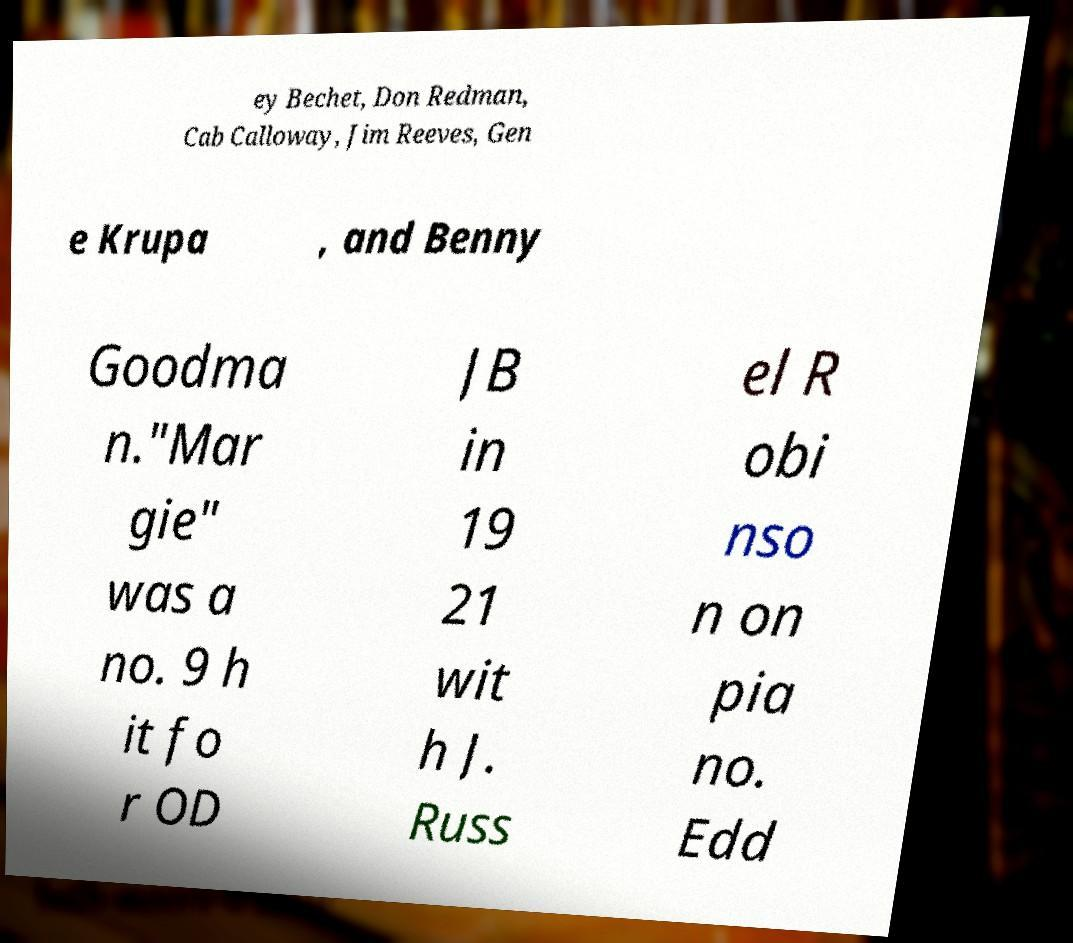I need the written content from this picture converted into text. Can you do that? ey Bechet, Don Redman, Cab Calloway, Jim Reeves, Gen e Krupa , and Benny Goodma n."Mar gie" was a no. 9 h it fo r OD JB in 19 21 wit h J. Russ el R obi nso n on pia no. Edd 